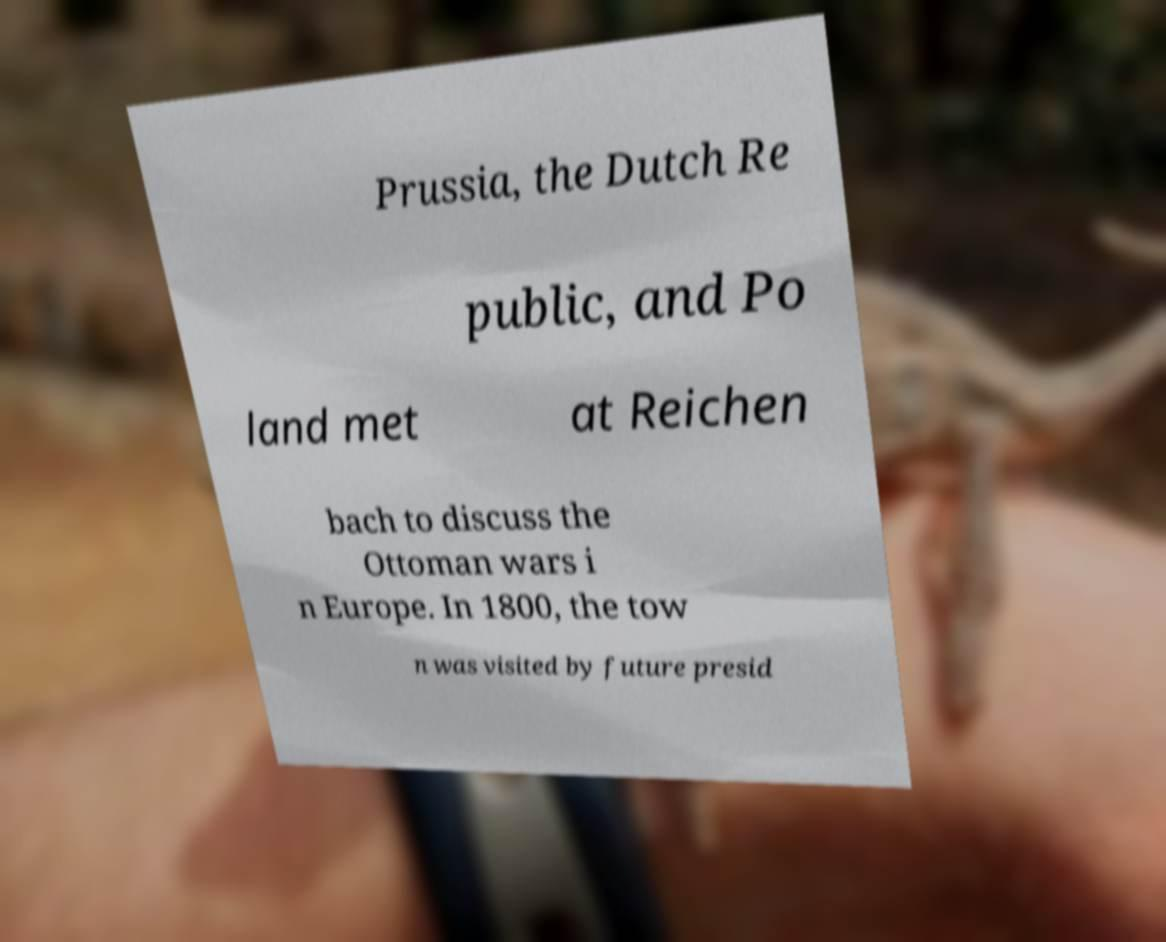There's text embedded in this image that I need extracted. Can you transcribe it verbatim? Prussia, the Dutch Re public, and Po land met at Reichen bach to discuss the Ottoman wars i n Europe. In 1800, the tow n was visited by future presid 